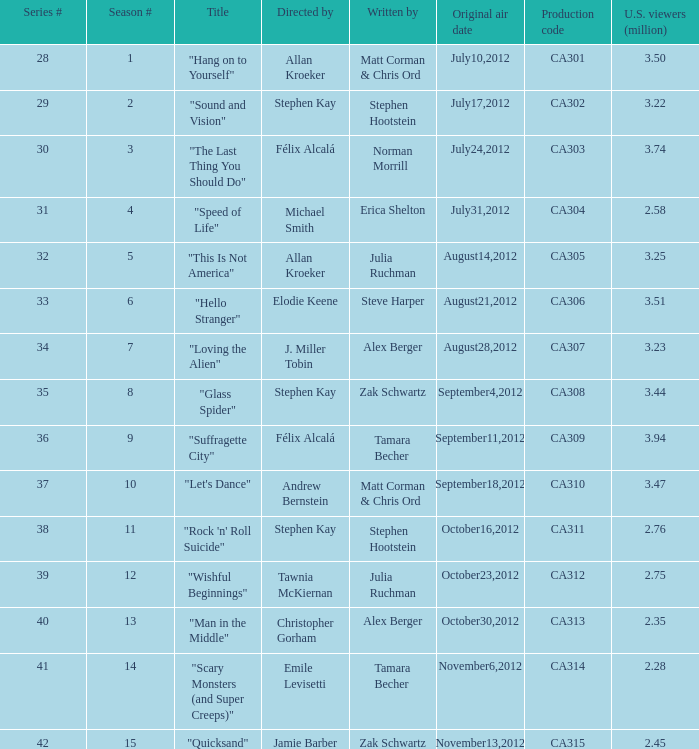Who directed the episode with production code ca311? Stephen Kay. Could you help me parse every detail presented in this table? {'header': ['Series #', 'Season #', 'Title', 'Directed by', 'Written by', 'Original air date', 'Production code', 'U.S. viewers (million)'], 'rows': [['28', '1', '"Hang on to Yourself"', 'Allan Kroeker', 'Matt Corman & Chris Ord', 'July10,2012', 'CA301', '3.50'], ['29', '2', '"Sound and Vision"', 'Stephen Kay', 'Stephen Hootstein', 'July17,2012', 'CA302', '3.22'], ['30', '3', '"The Last Thing You Should Do"', 'Félix Alcalá', 'Norman Morrill', 'July24,2012', 'CA303', '3.74'], ['31', '4', '"Speed of Life"', 'Michael Smith', 'Erica Shelton', 'July31,2012', 'CA304', '2.58'], ['32', '5', '"This Is Not America"', 'Allan Kroeker', 'Julia Ruchman', 'August14,2012', 'CA305', '3.25'], ['33', '6', '"Hello Stranger"', 'Elodie Keene', 'Steve Harper', 'August21,2012', 'CA306', '3.51'], ['34', '7', '"Loving the Alien"', 'J. Miller Tobin', 'Alex Berger', 'August28,2012', 'CA307', '3.23'], ['35', '8', '"Glass Spider"', 'Stephen Kay', 'Zak Schwartz', 'September4,2012', 'CA308', '3.44'], ['36', '9', '"Suffragette City"', 'Félix Alcalá', 'Tamara Becher', 'September11,2012', 'CA309', '3.94'], ['37', '10', '"Let\'s Dance"', 'Andrew Bernstein', 'Matt Corman & Chris Ord', 'September18,2012', 'CA310', '3.47'], ['38', '11', '"Rock \'n\' Roll Suicide"', 'Stephen Kay', 'Stephen Hootstein', 'October16,2012', 'CA311', '2.76'], ['39', '12', '"Wishful Beginnings"', 'Tawnia McKiernan', 'Julia Ruchman', 'October23,2012', 'CA312', '2.75'], ['40', '13', '"Man in the Middle"', 'Christopher Gorham', 'Alex Berger', 'October30,2012', 'CA313', '2.35'], ['41', '14', '"Scary Monsters (and Super Creeps)"', 'Emile Levisetti', 'Tamara Becher', 'November6,2012', 'CA314', '2.28'], ['42', '15', '"Quicksand"', 'Jamie Barber', 'Zak Schwartz', 'November13,2012', 'CA315', '2.45']]} 